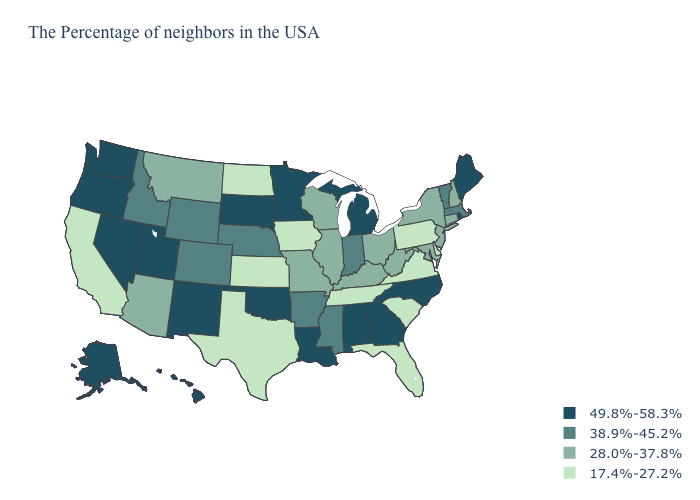What is the highest value in the West ?
Write a very short answer. 49.8%-58.3%. What is the lowest value in the USA?
Answer briefly. 17.4%-27.2%. Name the states that have a value in the range 49.8%-58.3%?
Keep it brief. Maine, Rhode Island, North Carolina, Georgia, Michigan, Alabama, Louisiana, Minnesota, Oklahoma, South Dakota, New Mexico, Utah, Nevada, Washington, Oregon, Alaska, Hawaii. What is the lowest value in the USA?
Give a very brief answer. 17.4%-27.2%. Among the states that border Oklahoma , which have the lowest value?
Give a very brief answer. Kansas, Texas. Among the states that border California , which have the lowest value?
Be succinct. Arizona. Name the states that have a value in the range 28.0%-37.8%?
Quick response, please. New Hampshire, Connecticut, New York, New Jersey, Maryland, West Virginia, Ohio, Kentucky, Wisconsin, Illinois, Missouri, Montana, Arizona. Among the states that border Wyoming , which have the highest value?
Answer briefly. South Dakota, Utah. What is the value of Arizona?
Be succinct. 28.0%-37.8%. Name the states that have a value in the range 28.0%-37.8%?
Keep it brief. New Hampshire, Connecticut, New York, New Jersey, Maryland, West Virginia, Ohio, Kentucky, Wisconsin, Illinois, Missouri, Montana, Arizona. Name the states that have a value in the range 38.9%-45.2%?
Keep it brief. Massachusetts, Vermont, Indiana, Mississippi, Arkansas, Nebraska, Wyoming, Colorado, Idaho. Does Colorado have a higher value than Arkansas?
Give a very brief answer. No. Which states hav the highest value in the MidWest?
Answer briefly. Michigan, Minnesota, South Dakota. Name the states that have a value in the range 49.8%-58.3%?
Answer briefly. Maine, Rhode Island, North Carolina, Georgia, Michigan, Alabama, Louisiana, Minnesota, Oklahoma, South Dakota, New Mexico, Utah, Nevada, Washington, Oregon, Alaska, Hawaii. 